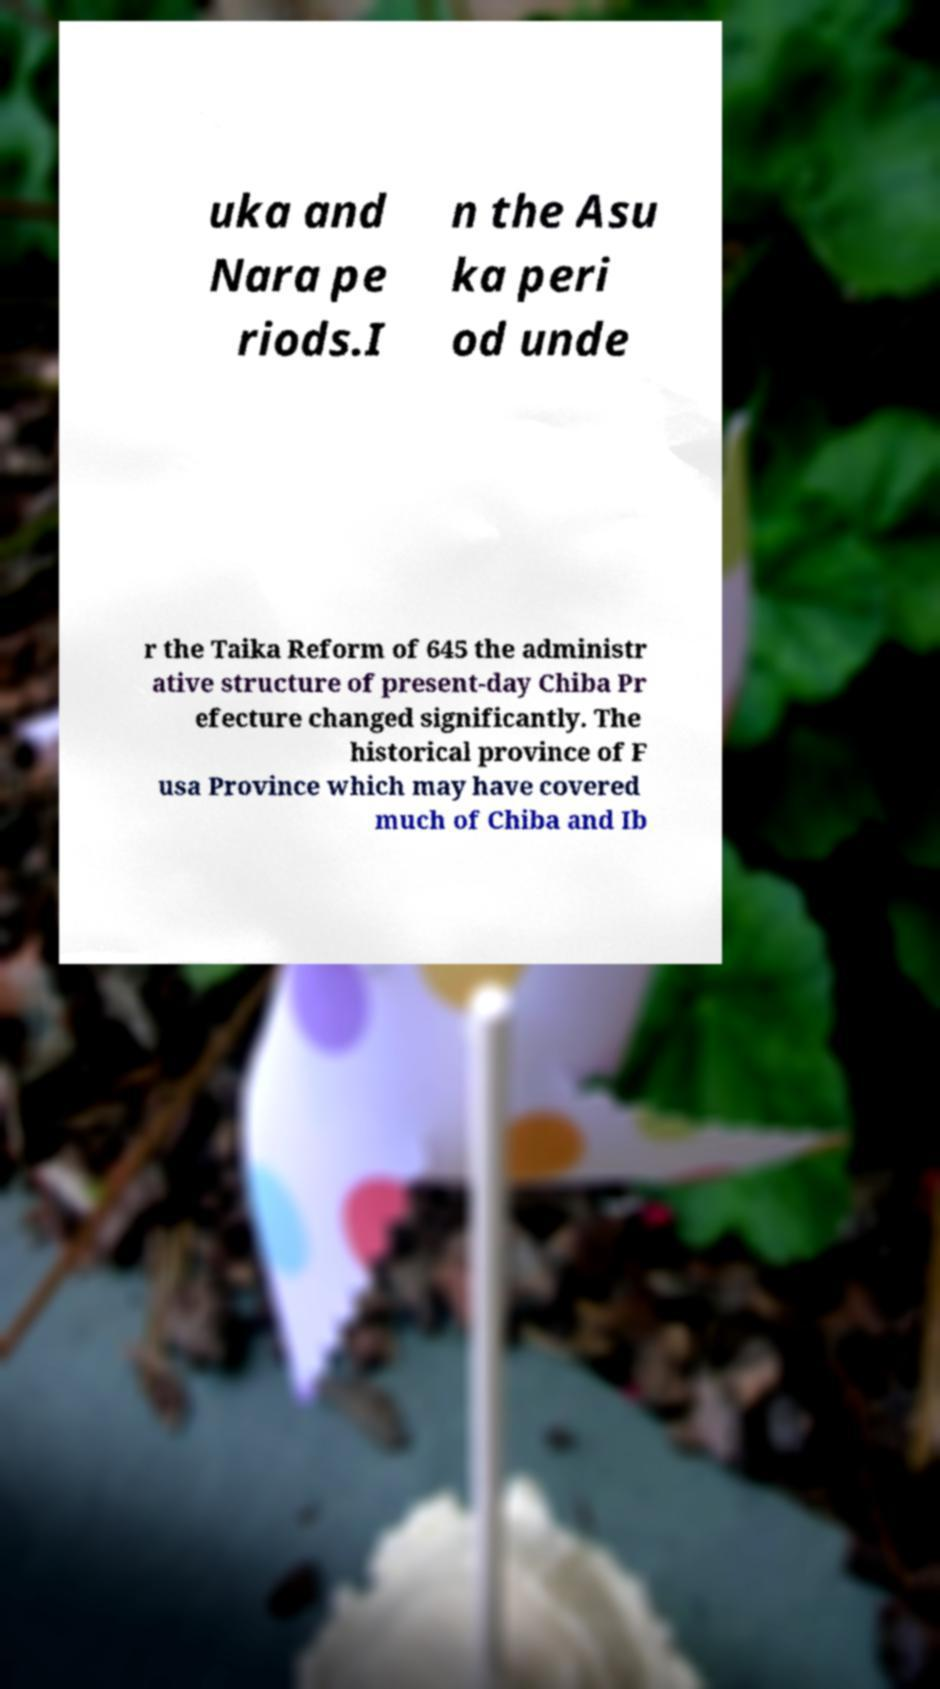Can you accurately transcribe the text from the provided image for me? uka and Nara pe riods.I n the Asu ka peri od unde r the Taika Reform of 645 the administr ative structure of present-day Chiba Pr efecture changed significantly. The historical province of F usa Province which may have covered much of Chiba and Ib 